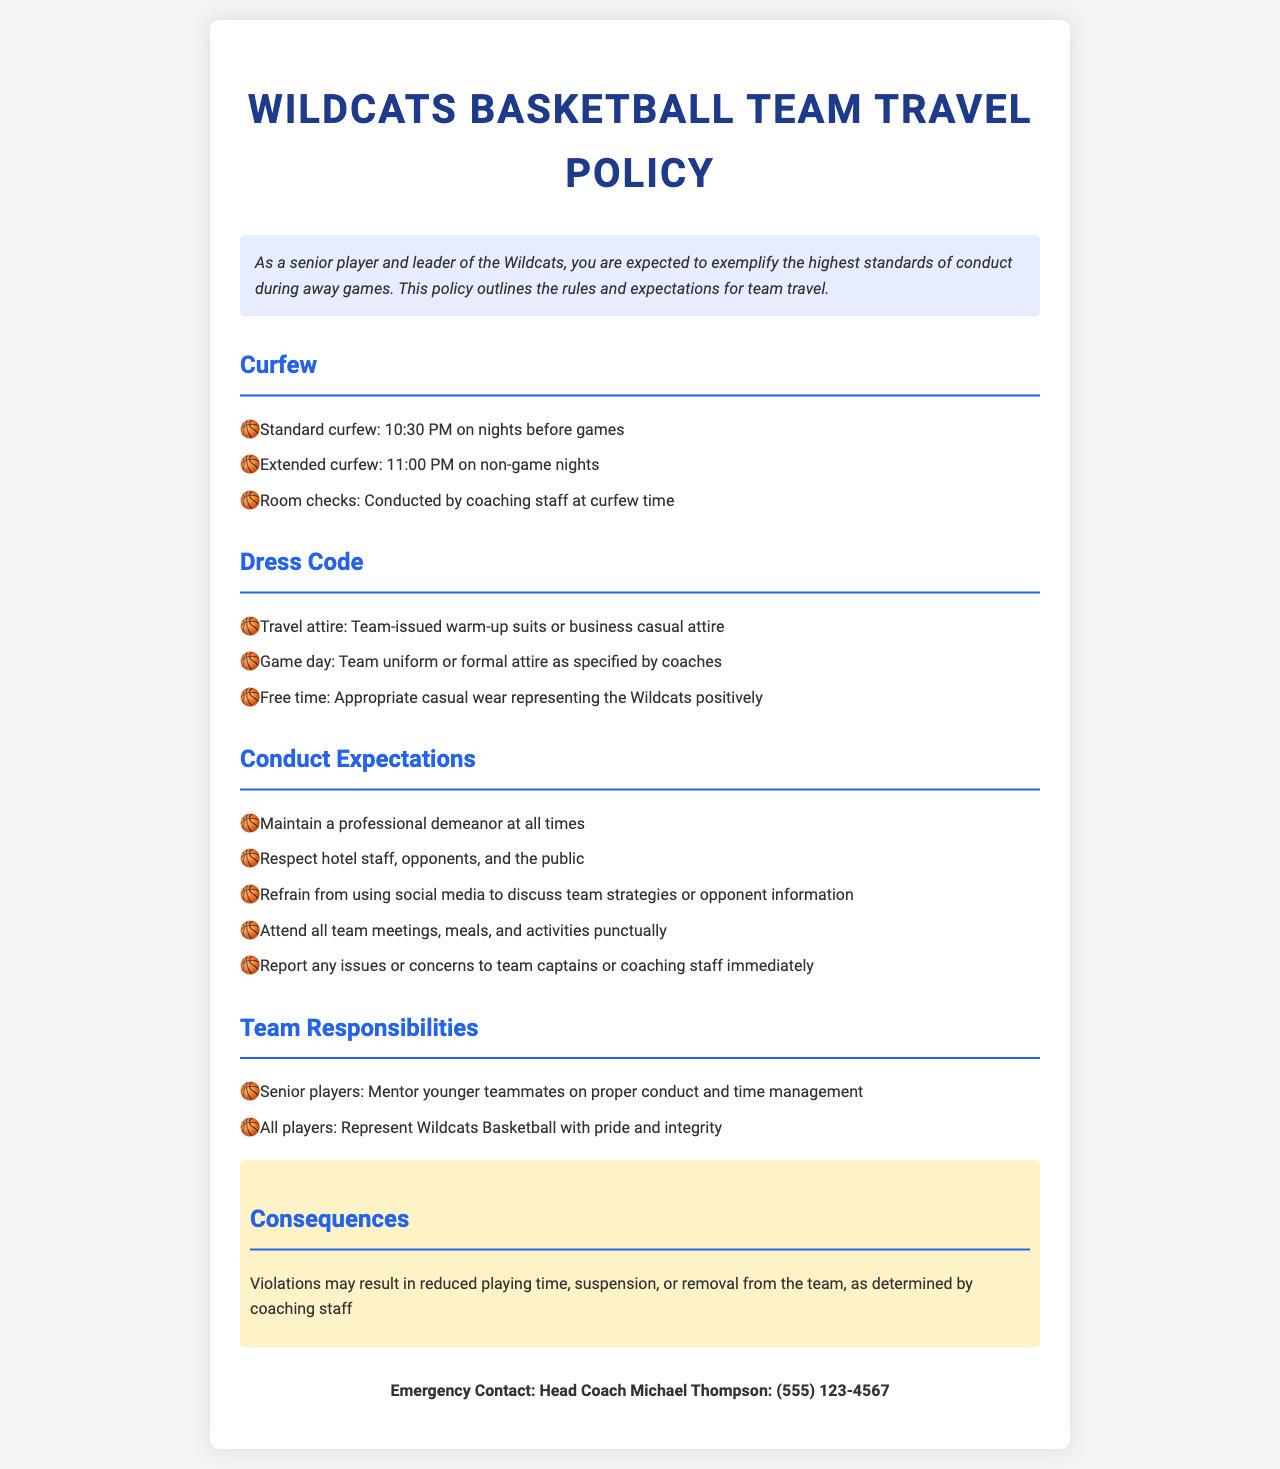What is the standard curfew time before games? The standard curfew is specified as 10:30 PM on nights before games.
Answer: 10:30 PM What should players wear for travel attire? The policy states that players should wear team-issued warm-up suits or business casual attire for travel.
Answer: Team-issued warm-up suits or business casual attire What is the consequence for policy violations? The document mentions that violations may result in reduced playing time, suspension, or removal from the team.
Answer: Reduced playing time, suspension, or removal from the team Who is responsible for conducting room checks? The policy specifies that room checks are conducted by the coaching staff at curfew time.
Answer: Coaching staff What type of conduct is expected from players? The policy outlines that players must maintain a professional demeanor at all times.
Answer: Professional demeanor What is the extended curfew time on non-game nights? The extended curfew for non-game nights is indicated to be 11:00 PM.
Answer: 11:00 PM Who should players report issues or concerns to? Players are instructed to report any issues or concerns to team captains or coaching staff.
Answer: Team captains or coaching staff What attire is required on game day? The document specifies that players should wear the team uniform or formal attire as specified by coaches on game day.
Answer: Team uniform or formal attire as specified by coaches 